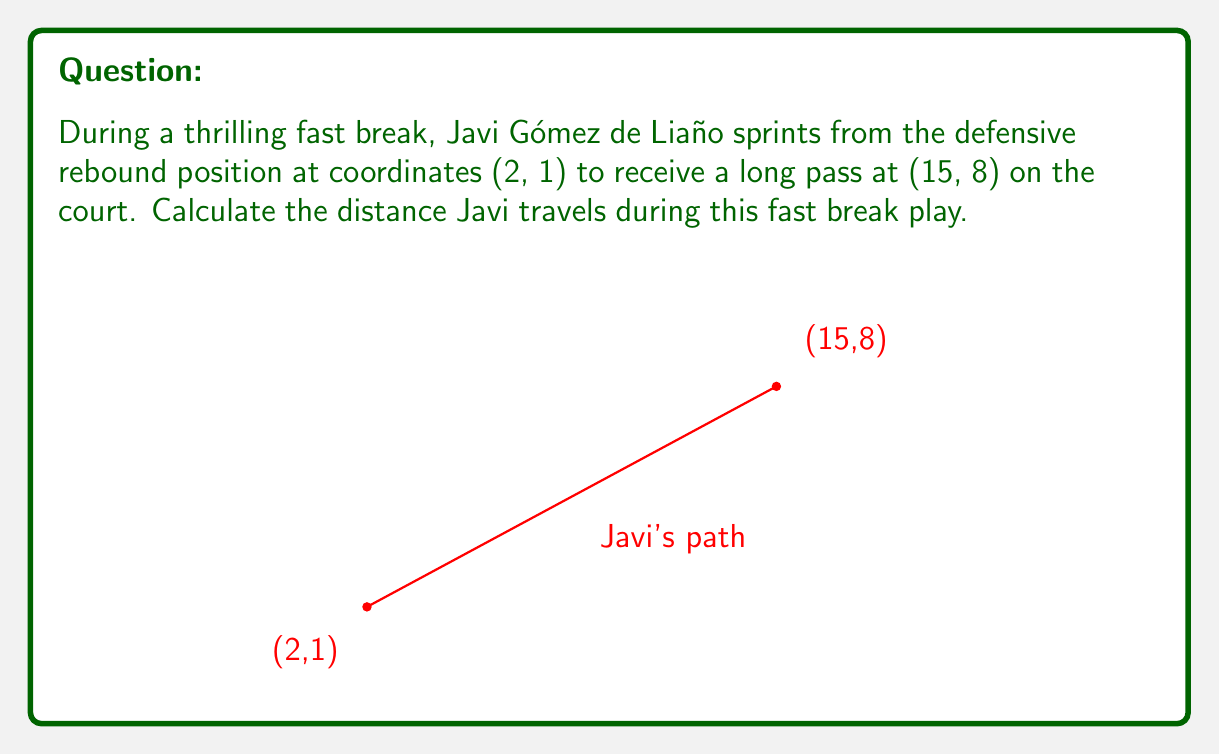Show me your answer to this math problem. To find the distance Javi Gómez de Liaño travels, we need to use the distance formula derived from the Pythagorean theorem:

$$ d = \sqrt{(x_2 - x_1)^2 + (y_2 - y_1)^2} $$

Where $(x_1, y_1)$ is the starting point and $(x_2, y_2)$ is the ending point.

Given:
- Starting point: $(2, 1)$
- Ending point: $(15, 8)$

Let's substitute these values into the formula:

$$ d = \sqrt{(15 - 2)^2 + (8 - 1)^2} $$

Now, let's solve step by step:

1) Simplify the expressions inside the parentheses:
   $$ d = \sqrt{13^2 + 7^2} $$

2) Calculate the squares:
   $$ d = \sqrt{169 + 49} $$

3) Add the numbers under the square root:
   $$ d = \sqrt{218} $$

4) Simplify the square root:
   $$ d = \sqrt{2 \times 109} = \sqrt{2} \times \sqrt{109} \approx 14.76 $$

Therefore, Javi Gómez de Liaño travels approximately 14.76 units (e.g., meters) during this fast break play.
Answer: $\sqrt{218} \approx 14.76$ units 